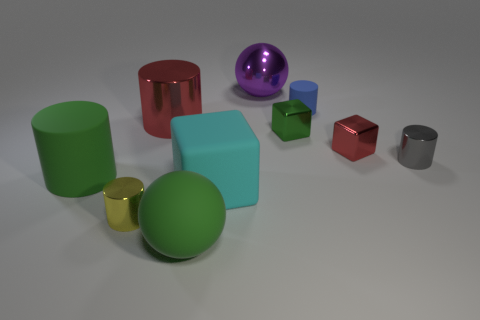What number of objects are left of the large cyan rubber object and behind the cyan thing?
Your answer should be compact. 2. Is the material of the yellow thing the same as the green ball?
Ensure brevity in your answer.  No. There is a tiny thing that is in front of the small metallic cylinder on the right side of the big metal object that is to the left of the big purple sphere; what is its shape?
Ensure brevity in your answer.  Cylinder. There is a thing that is behind the tiny yellow cylinder and on the left side of the red cylinder; what material is it?
Ensure brevity in your answer.  Rubber. The ball behind the red object that is on the right side of the green matte thing to the right of the green matte cylinder is what color?
Your answer should be very brief. Purple. What number of blue things are spheres or small cylinders?
Ensure brevity in your answer.  1. What number of other objects are the same size as the cyan thing?
Provide a succinct answer. 4. What number of red cylinders are there?
Offer a terse response. 1. Are there any other things that are the same shape as the green shiny object?
Your answer should be compact. Yes. Are the red thing that is in front of the small green cube and the small block to the left of the small matte object made of the same material?
Offer a very short reply. Yes. 